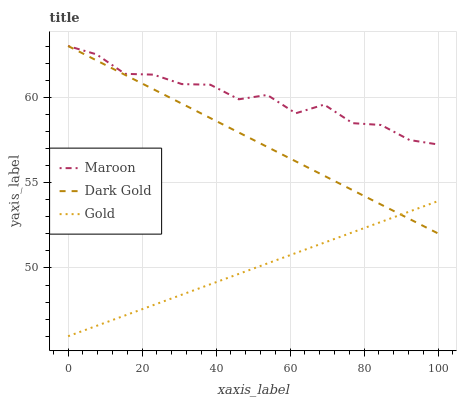Does Gold have the minimum area under the curve?
Answer yes or no. Yes. Does Maroon have the maximum area under the curve?
Answer yes or no. Yes. Does Dark Gold have the minimum area under the curve?
Answer yes or no. No. Does Dark Gold have the maximum area under the curve?
Answer yes or no. No. Is Dark Gold the smoothest?
Answer yes or no. Yes. Is Maroon the roughest?
Answer yes or no. Yes. Is Maroon the smoothest?
Answer yes or no. No. Is Dark Gold the roughest?
Answer yes or no. No. Does Gold have the lowest value?
Answer yes or no. Yes. Does Dark Gold have the lowest value?
Answer yes or no. No. Does Dark Gold have the highest value?
Answer yes or no. Yes. Is Gold less than Maroon?
Answer yes or no. Yes. Is Maroon greater than Gold?
Answer yes or no. Yes. Does Gold intersect Dark Gold?
Answer yes or no. Yes. Is Gold less than Dark Gold?
Answer yes or no. No. Is Gold greater than Dark Gold?
Answer yes or no. No. Does Gold intersect Maroon?
Answer yes or no. No. 